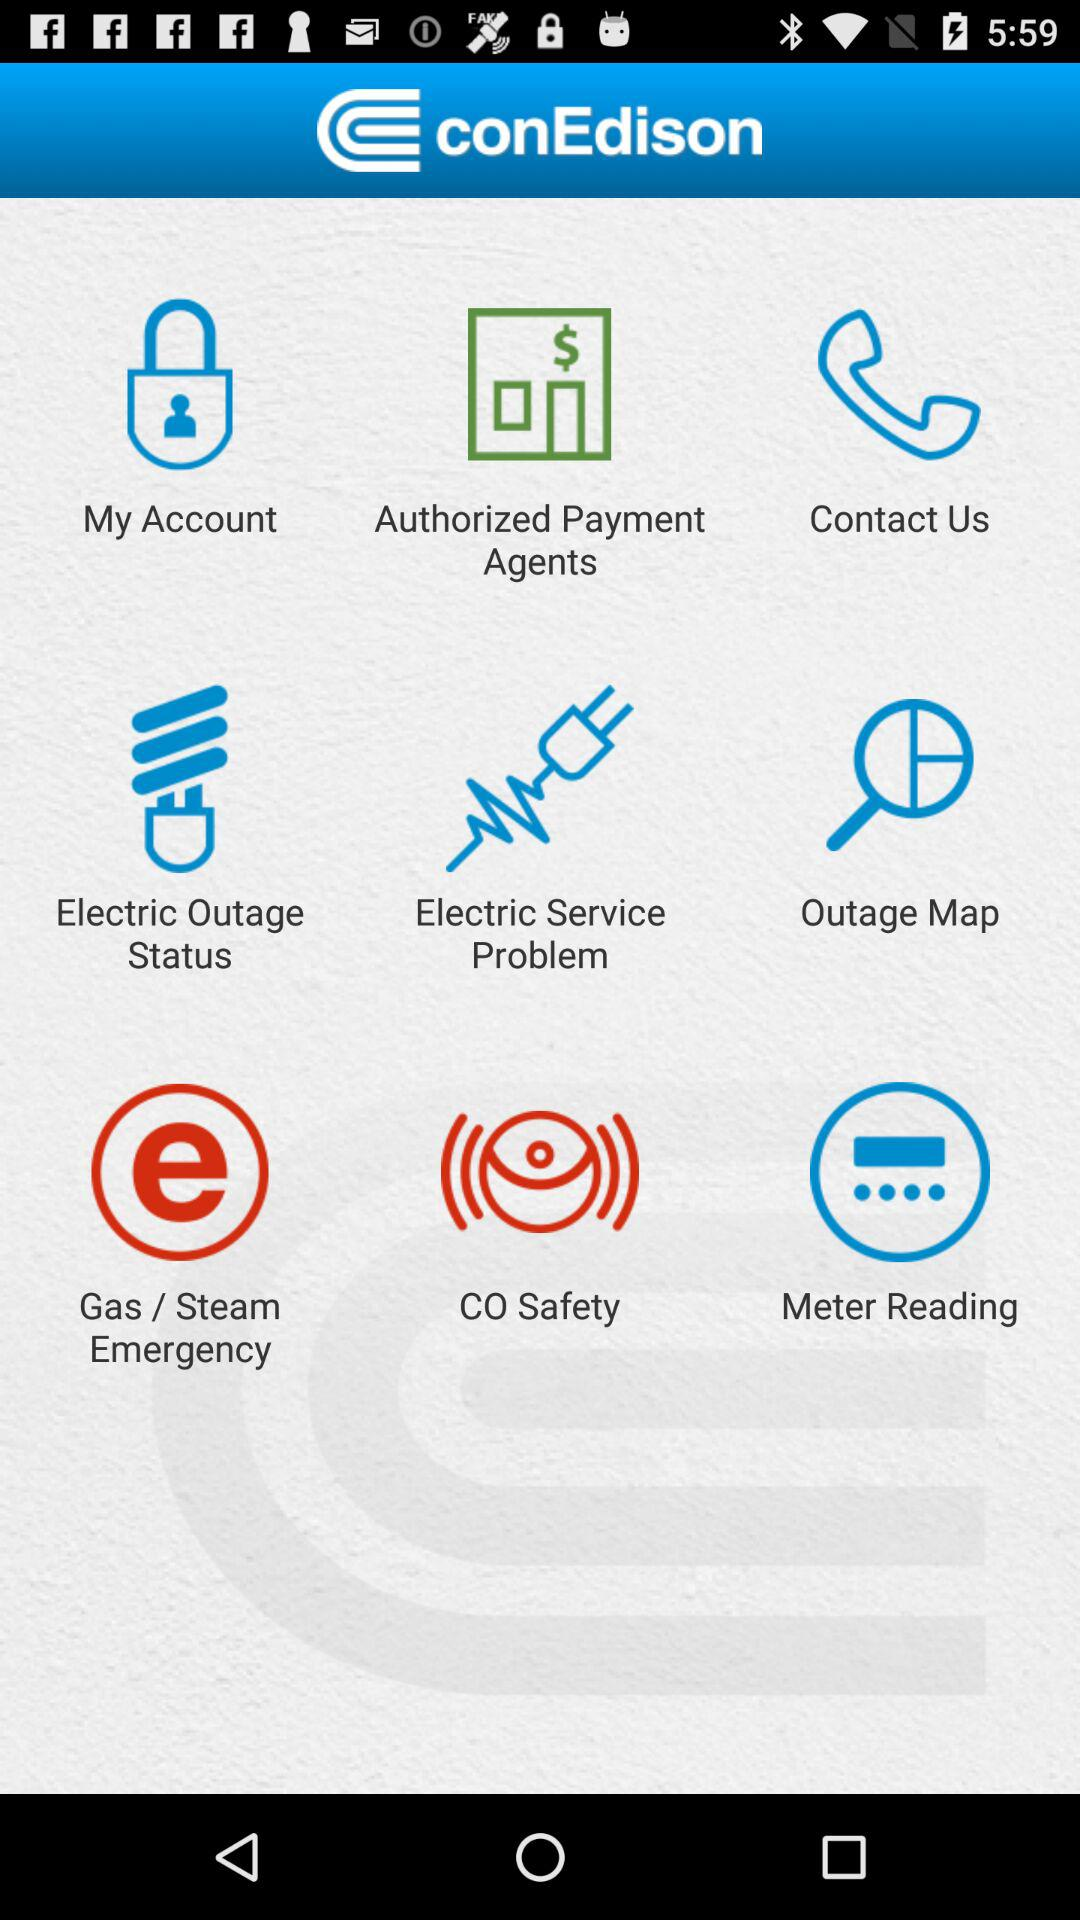What is the application name? The application name is "conEdison". 